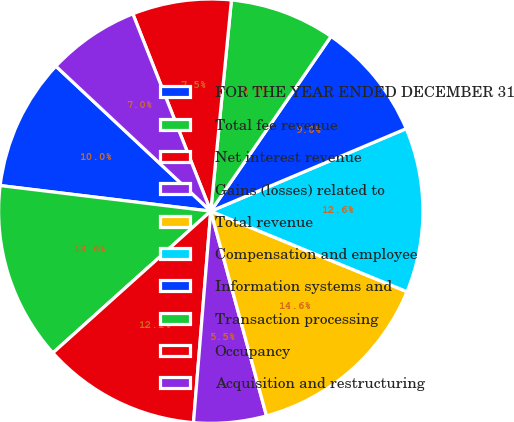Convert chart to OTSL. <chart><loc_0><loc_0><loc_500><loc_500><pie_chart><fcel>FOR THE YEAR ENDED DECEMBER 31<fcel>Total fee revenue<fcel>Net interest revenue<fcel>Gains (losses) related to<fcel>Total revenue<fcel>Compensation and employee<fcel>Information systems and<fcel>Transaction processing<fcel>Occupancy<fcel>Acquisition and restructuring<nl><fcel>10.05%<fcel>13.57%<fcel>12.06%<fcel>5.53%<fcel>14.57%<fcel>12.56%<fcel>9.05%<fcel>8.04%<fcel>7.54%<fcel>7.04%<nl></chart> 